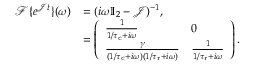<formula> <loc_0><loc_0><loc_500><loc_500>\begin{array} { r l } { \mathcal { F } \{ e ^ { \mathcal { J } t } \} ( \omega ) } & { = ( i \omega \mathbb { I } _ { 2 } - \mathcal { J } ) ^ { - 1 } , } \\ & { = \left ( \begin{array} { l l } { \frac { 1 } { 1 / { \tau _ { c } } + i \omega } } & { 0 } \\ { \frac { \gamma } { ( 1 / { \tau _ { c } } + i \omega ) ( 1 / { \tau _ { r } } + i \omega ) } } & { \frac { 1 } { 1 / { \tau _ { r } } + i \omega } } \end{array} \right ) . } \end{array}</formula> 